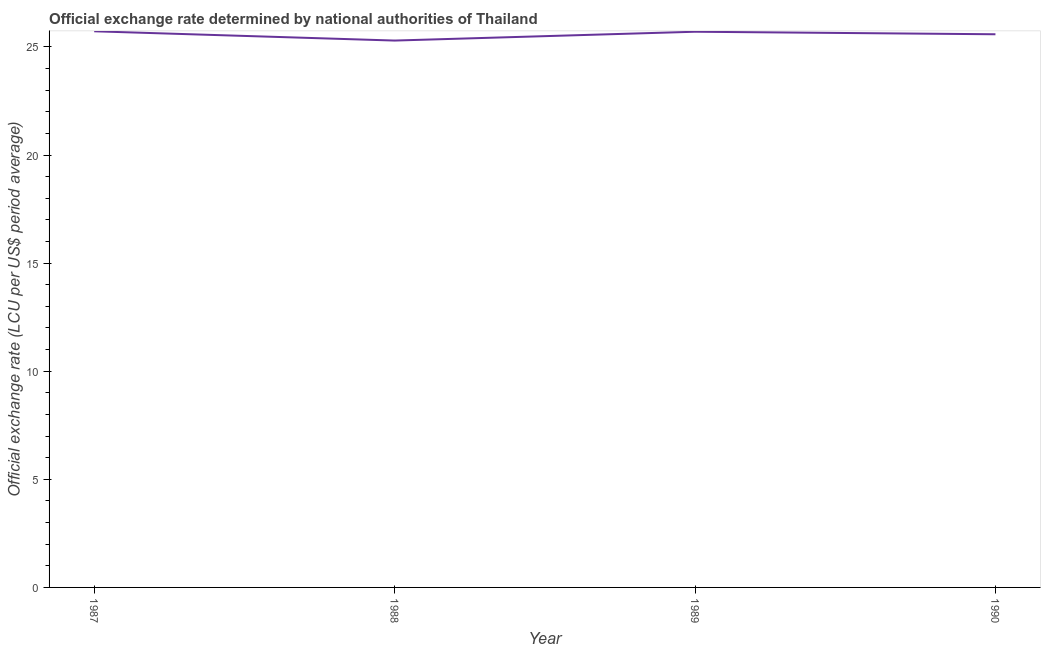What is the official exchange rate in 1990?
Offer a very short reply. 25.59. Across all years, what is the maximum official exchange rate?
Make the answer very short. 25.72. Across all years, what is the minimum official exchange rate?
Your answer should be very brief. 25.29. In which year was the official exchange rate maximum?
Your answer should be very brief. 1987. What is the sum of the official exchange rate?
Your answer should be very brief. 102.3. What is the difference between the official exchange rate in 1987 and 1989?
Ensure brevity in your answer.  0.02. What is the average official exchange rate per year?
Offer a very short reply. 25.58. What is the median official exchange rate?
Your answer should be very brief. 25.64. What is the ratio of the official exchange rate in 1987 to that in 1989?
Offer a very short reply. 1. What is the difference between the highest and the second highest official exchange rate?
Your answer should be very brief. 0.02. Is the sum of the official exchange rate in 1987 and 1990 greater than the maximum official exchange rate across all years?
Keep it short and to the point. Yes. What is the difference between the highest and the lowest official exchange rate?
Your answer should be compact. 0.43. In how many years, is the official exchange rate greater than the average official exchange rate taken over all years?
Offer a terse response. 3. How many lines are there?
Offer a very short reply. 1. Are the values on the major ticks of Y-axis written in scientific E-notation?
Your answer should be compact. No. What is the title of the graph?
Provide a succinct answer. Official exchange rate determined by national authorities of Thailand. What is the label or title of the X-axis?
Ensure brevity in your answer.  Year. What is the label or title of the Y-axis?
Provide a succinct answer. Official exchange rate (LCU per US$ period average). What is the Official exchange rate (LCU per US$ period average) in 1987?
Keep it short and to the point. 25.72. What is the Official exchange rate (LCU per US$ period average) in 1988?
Make the answer very short. 25.29. What is the Official exchange rate (LCU per US$ period average) in 1989?
Give a very brief answer. 25.7. What is the Official exchange rate (LCU per US$ period average) in 1990?
Provide a short and direct response. 25.59. What is the difference between the Official exchange rate (LCU per US$ period average) in 1987 and 1988?
Ensure brevity in your answer.  0.43. What is the difference between the Official exchange rate (LCU per US$ period average) in 1987 and 1989?
Give a very brief answer. 0.02. What is the difference between the Official exchange rate (LCU per US$ period average) in 1987 and 1990?
Make the answer very short. 0.14. What is the difference between the Official exchange rate (LCU per US$ period average) in 1988 and 1989?
Offer a very short reply. -0.41. What is the difference between the Official exchange rate (LCU per US$ period average) in 1988 and 1990?
Give a very brief answer. -0.29. What is the difference between the Official exchange rate (LCU per US$ period average) in 1989 and 1990?
Provide a succinct answer. 0.12. What is the ratio of the Official exchange rate (LCU per US$ period average) in 1987 to that in 1988?
Make the answer very short. 1.02. What is the ratio of the Official exchange rate (LCU per US$ period average) in 1988 to that in 1989?
Keep it short and to the point. 0.98. What is the ratio of the Official exchange rate (LCU per US$ period average) in 1988 to that in 1990?
Offer a terse response. 0.99. What is the ratio of the Official exchange rate (LCU per US$ period average) in 1989 to that in 1990?
Your response must be concise. 1. 